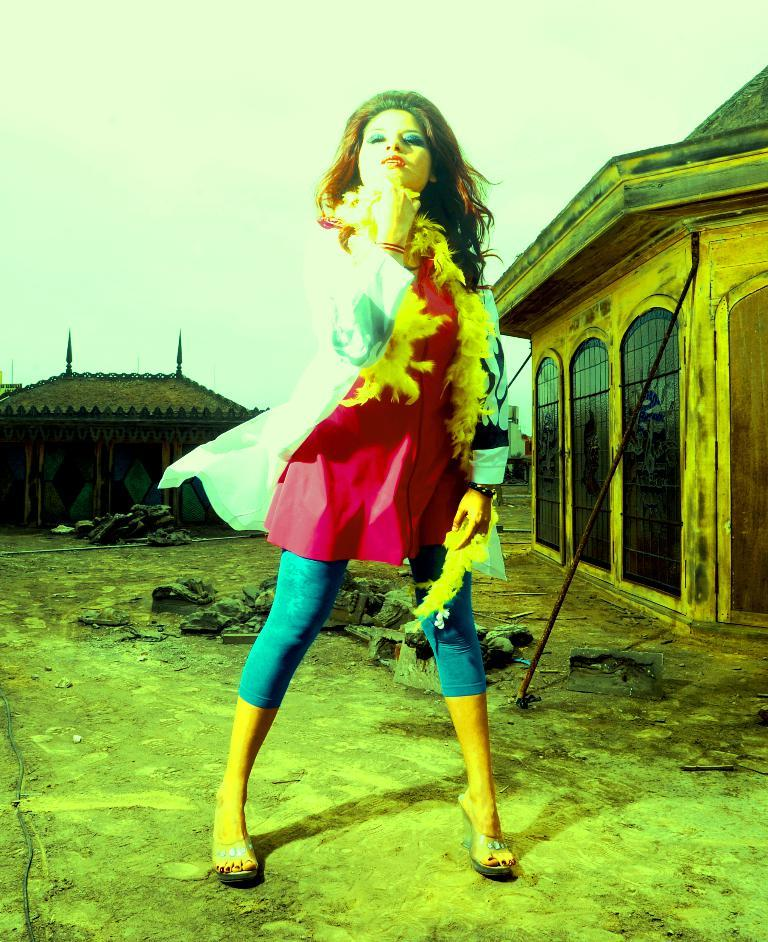Who is present in the image? There is a woman in the image. What is the woman doing in the image? The woman is standing. What can be seen in the background of the image? There are houses visible behind the woman. What type of caption is written on the ladybug in the image? There is no ladybug present in the image, and therefore no caption can be observed. 